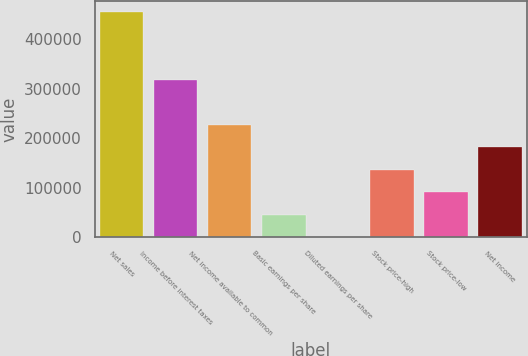Convert chart. <chart><loc_0><loc_0><loc_500><loc_500><bar_chart><fcel>Net sales<fcel>Income before interest taxes<fcel>Net income available to common<fcel>Basic earnings per share<fcel>Diluted earnings per share<fcel>Stock price-high<fcel>Stock price-low<fcel>Net income<nl><fcel>454666<fcel>318266<fcel>227333<fcel>45466.8<fcel>0.25<fcel>136400<fcel>90933.4<fcel>181867<nl></chart> 